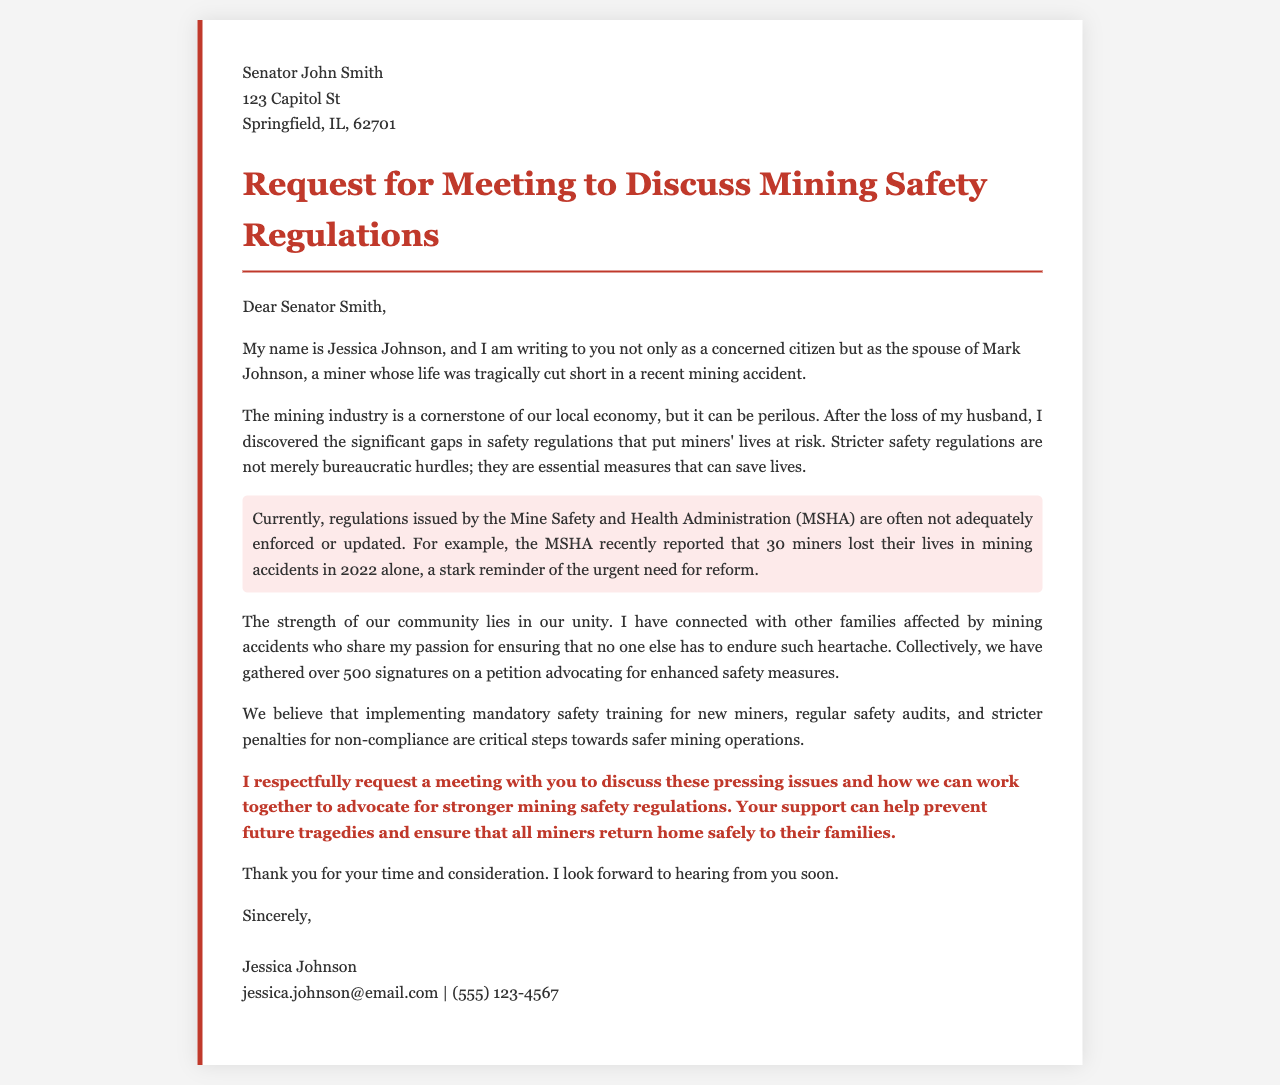What is the name of the sender? The sender of the letter is clearly stated in the signature section as Jessica Johnson.
Answer: Jessica Johnson What was the cause of Mark Johnson's death? The letter indicates that Mark Johnson's life was tragically cut short in a mining accident.
Answer: Mining accident How many miners lost their lives in 2022 according to the MSHA? The letter specifically states that 30 miners lost their lives in mining accidents in 2022.
Answer: 30 What does the petition advocate for? The petition mentioned in the letter advocates for enhanced safety measures in the mining industry.
Answer: Enhanced safety measures How many signatures have been collected for the petition? The letter mentions that over 500 signatures have been gathered on the petition.
Answer: Over 500 What is requested in the letter? The letter includes a request for a meeting to discuss mining safety regulations.
Answer: A meeting What is the position of Jessica Johnson? Jessica Johnson identifies herself as a concerned citizen and the spouse of a miner who passed away.
Answer: Spouse of a miner What is the highlighted issue in the letter? The highlighted issue indicates that safety regulations are not adequately enforced or updated.
Answer: Inadequate enforcement of regulations 